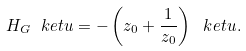Convert formula to latex. <formula><loc_0><loc_0><loc_500><loc_500>H _ { G } \ k e t { u } = - \left ( z _ { 0 } + \frac { 1 } { z _ { 0 } } \right ) \ k e t { u } .</formula> 